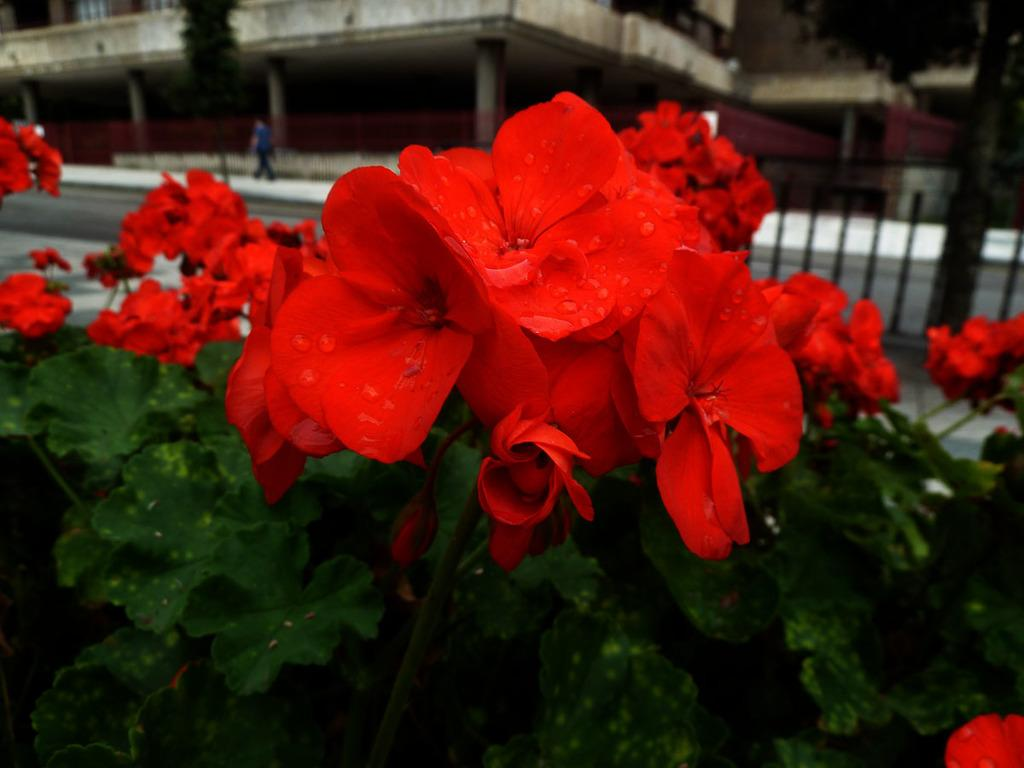What type of flowers can be seen in the image? There are red flowers in the image. What color are the leaves associated with the flowers? There are green leaves in the image. What can be seen in the background of the image? There is a building with pillars and a person walking in the background. What type of rice is being harvested in the image? There is no rice or harvesting activity present in the image. 